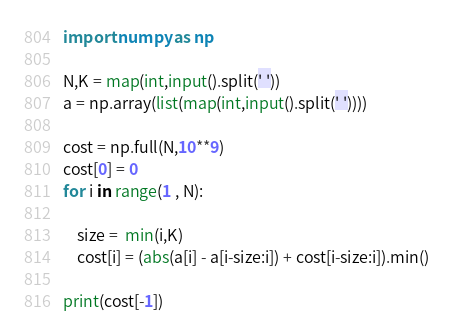Convert code to text. <code><loc_0><loc_0><loc_500><loc_500><_Python_>import numpy as np

N,K = map(int,input().split(' '))
a = np.array(list(map(int,input().split(' '))))

cost = np.full(N,10**9)
cost[0] = 0
for i in range(1 , N):
    
    size =  min(i,K)
    cost[i] = (abs(a[i] - a[i-size:i]) + cost[i-size:i]).min()

print(cost[-1])</code> 